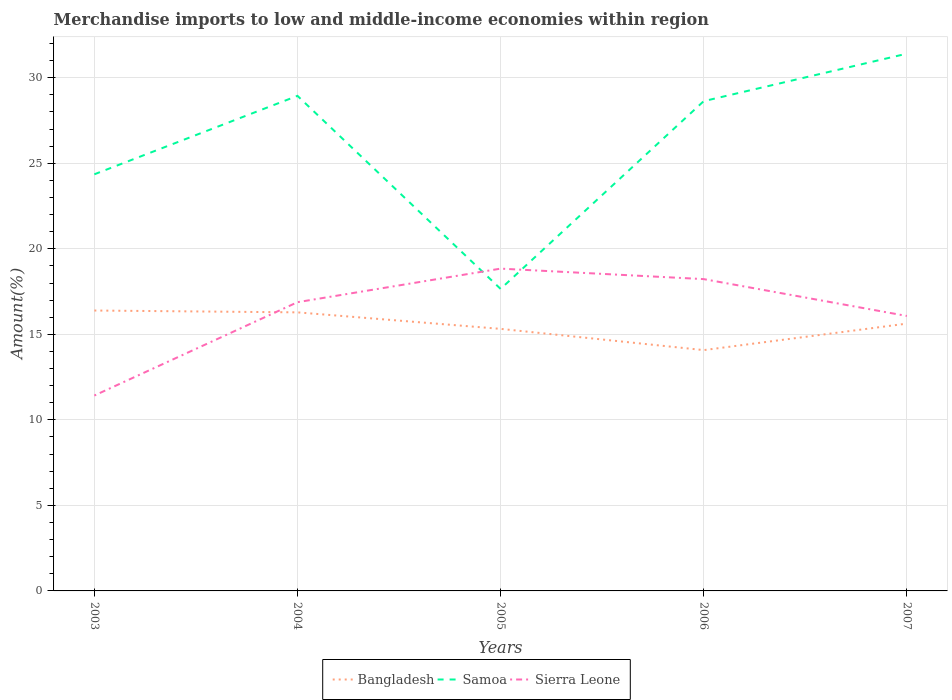Is the number of lines equal to the number of legend labels?
Give a very brief answer. Yes. Across all years, what is the maximum percentage of amount earned from merchandise imports in Samoa?
Provide a succinct answer. 17.66. In which year was the percentage of amount earned from merchandise imports in Bangladesh maximum?
Ensure brevity in your answer.  2006. What is the total percentage of amount earned from merchandise imports in Bangladesh in the graph?
Give a very brief answer. 1.24. What is the difference between the highest and the second highest percentage of amount earned from merchandise imports in Samoa?
Ensure brevity in your answer.  13.75. What is the difference between the highest and the lowest percentage of amount earned from merchandise imports in Samoa?
Provide a short and direct response. 3. Is the percentage of amount earned from merchandise imports in Bangladesh strictly greater than the percentage of amount earned from merchandise imports in Samoa over the years?
Offer a terse response. Yes. How many lines are there?
Ensure brevity in your answer.  3. What is the difference between two consecutive major ticks on the Y-axis?
Keep it short and to the point. 5. How are the legend labels stacked?
Keep it short and to the point. Horizontal. What is the title of the graph?
Your response must be concise. Merchandise imports to low and middle-income economies within region. Does "Grenada" appear as one of the legend labels in the graph?
Your answer should be very brief. No. What is the label or title of the Y-axis?
Provide a short and direct response. Amount(%). What is the Amount(%) of Bangladesh in 2003?
Make the answer very short. 16.39. What is the Amount(%) in Samoa in 2003?
Provide a succinct answer. 24.36. What is the Amount(%) of Sierra Leone in 2003?
Offer a terse response. 11.42. What is the Amount(%) in Bangladesh in 2004?
Make the answer very short. 16.28. What is the Amount(%) in Samoa in 2004?
Offer a terse response. 28.94. What is the Amount(%) of Sierra Leone in 2004?
Make the answer very short. 16.88. What is the Amount(%) in Bangladesh in 2005?
Your answer should be compact. 15.32. What is the Amount(%) of Samoa in 2005?
Provide a short and direct response. 17.66. What is the Amount(%) of Sierra Leone in 2005?
Keep it short and to the point. 18.84. What is the Amount(%) in Bangladesh in 2006?
Your answer should be very brief. 14.08. What is the Amount(%) in Samoa in 2006?
Offer a terse response. 28.63. What is the Amount(%) of Sierra Leone in 2006?
Offer a very short reply. 18.23. What is the Amount(%) of Bangladesh in 2007?
Your response must be concise. 15.63. What is the Amount(%) in Samoa in 2007?
Give a very brief answer. 31.41. What is the Amount(%) in Sierra Leone in 2007?
Make the answer very short. 16.07. Across all years, what is the maximum Amount(%) of Bangladesh?
Offer a terse response. 16.39. Across all years, what is the maximum Amount(%) in Samoa?
Your answer should be compact. 31.41. Across all years, what is the maximum Amount(%) of Sierra Leone?
Make the answer very short. 18.84. Across all years, what is the minimum Amount(%) of Bangladesh?
Your answer should be compact. 14.08. Across all years, what is the minimum Amount(%) in Samoa?
Your answer should be compact. 17.66. Across all years, what is the minimum Amount(%) in Sierra Leone?
Your response must be concise. 11.42. What is the total Amount(%) of Bangladesh in the graph?
Make the answer very short. 77.7. What is the total Amount(%) in Samoa in the graph?
Offer a very short reply. 130.99. What is the total Amount(%) in Sierra Leone in the graph?
Give a very brief answer. 81.44. What is the difference between the Amount(%) in Bangladesh in 2003 and that in 2004?
Your answer should be very brief. 0.11. What is the difference between the Amount(%) of Samoa in 2003 and that in 2004?
Your answer should be compact. -4.59. What is the difference between the Amount(%) in Sierra Leone in 2003 and that in 2004?
Your response must be concise. -5.46. What is the difference between the Amount(%) of Bangladesh in 2003 and that in 2005?
Offer a terse response. 1.07. What is the difference between the Amount(%) of Samoa in 2003 and that in 2005?
Your answer should be compact. 6.7. What is the difference between the Amount(%) in Sierra Leone in 2003 and that in 2005?
Your answer should be very brief. -7.42. What is the difference between the Amount(%) in Bangladesh in 2003 and that in 2006?
Your answer should be very brief. 2.31. What is the difference between the Amount(%) in Samoa in 2003 and that in 2006?
Your response must be concise. -4.28. What is the difference between the Amount(%) in Sierra Leone in 2003 and that in 2006?
Give a very brief answer. -6.81. What is the difference between the Amount(%) of Bangladesh in 2003 and that in 2007?
Your answer should be compact. 0.76. What is the difference between the Amount(%) of Samoa in 2003 and that in 2007?
Your answer should be compact. -7.05. What is the difference between the Amount(%) of Sierra Leone in 2003 and that in 2007?
Provide a short and direct response. -4.65. What is the difference between the Amount(%) of Bangladesh in 2004 and that in 2005?
Provide a succinct answer. 0.97. What is the difference between the Amount(%) in Samoa in 2004 and that in 2005?
Give a very brief answer. 11.29. What is the difference between the Amount(%) of Sierra Leone in 2004 and that in 2005?
Provide a short and direct response. -1.96. What is the difference between the Amount(%) in Bangladesh in 2004 and that in 2006?
Your response must be concise. 2.21. What is the difference between the Amount(%) in Samoa in 2004 and that in 2006?
Make the answer very short. 0.31. What is the difference between the Amount(%) in Sierra Leone in 2004 and that in 2006?
Give a very brief answer. -1.35. What is the difference between the Amount(%) of Bangladesh in 2004 and that in 2007?
Provide a succinct answer. 0.66. What is the difference between the Amount(%) in Samoa in 2004 and that in 2007?
Make the answer very short. -2.47. What is the difference between the Amount(%) in Sierra Leone in 2004 and that in 2007?
Provide a short and direct response. 0.81. What is the difference between the Amount(%) in Bangladesh in 2005 and that in 2006?
Your response must be concise. 1.24. What is the difference between the Amount(%) of Samoa in 2005 and that in 2006?
Your answer should be very brief. -10.98. What is the difference between the Amount(%) of Sierra Leone in 2005 and that in 2006?
Your answer should be compact. 0.61. What is the difference between the Amount(%) in Bangladesh in 2005 and that in 2007?
Your answer should be compact. -0.31. What is the difference between the Amount(%) of Samoa in 2005 and that in 2007?
Your answer should be very brief. -13.75. What is the difference between the Amount(%) of Sierra Leone in 2005 and that in 2007?
Keep it short and to the point. 2.77. What is the difference between the Amount(%) in Bangladesh in 2006 and that in 2007?
Provide a succinct answer. -1.55. What is the difference between the Amount(%) in Samoa in 2006 and that in 2007?
Give a very brief answer. -2.78. What is the difference between the Amount(%) in Sierra Leone in 2006 and that in 2007?
Provide a succinct answer. 2.15. What is the difference between the Amount(%) in Bangladesh in 2003 and the Amount(%) in Samoa in 2004?
Give a very brief answer. -12.55. What is the difference between the Amount(%) of Bangladesh in 2003 and the Amount(%) of Sierra Leone in 2004?
Your answer should be very brief. -0.49. What is the difference between the Amount(%) in Samoa in 2003 and the Amount(%) in Sierra Leone in 2004?
Provide a short and direct response. 7.48. What is the difference between the Amount(%) in Bangladesh in 2003 and the Amount(%) in Samoa in 2005?
Make the answer very short. -1.26. What is the difference between the Amount(%) of Bangladesh in 2003 and the Amount(%) of Sierra Leone in 2005?
Your response must be concise. -2.45. What is the difference between the Amount(%) of Samoa in 2003 and the Amount(%) of Sierra Leone in 2005?
Offer a terse response. 5.51. What is the difference between the Amount(%) of Bangladesh in 2003 and the Amount(%) of Samoa in 2006?
Offer a very short reply. -12.24. What is the difference between the Amount(%) in Bangladesh in 2003 and the Amount(%) in Sierra Leone in 2006?
Give a very brief answer. -1.84. What is the difference between the Amount(%) of Samoa in 2003 and the Amount(%) of Sierra Leone in 2006?
Offer a terse response. 6.13. What is the difference between the Amount(%) in Bangladesh in 2003 and the Amount(%) in Samoa in 2007?
Provide a short and direct response. -15.02. What is the difference between the Amount(%) of Bangladesh in 2003 and the Amount(%) of Sierra Leone in 2007?
Offer a terse response. 0.32. What is the difference between the Amount(%) in Samoa in 2003 and the Amount(%) in Sierra Leone in 2007?
Keep it short and to the point. 8.28. What is the difference between the Amount(%) in Bangladesh in 2004 and the Amount(%) in Samoa in 2005?
Provide a short and direct response. -1.37. What is the difference between the Amount(%) of Bangladesh in 2004 and the Amount(%) of Sierra Leone in 2005?
Make the answer very short. -2.56. What is the difference between the Amount(%) in Samoa in 2004 and the Amount(%) in Sierra Leone in 2005?
Keep it short and to the point. 10.1. What is the difference between the Amount(%) in Bangladesh in 2004 and the Amount(%) in Samoa in 2006?
Provide a short and direct response. -12.35. What is the difference between the Amount(%) in Bangladesh in 2004 and the Amount(%) in Sierra Leone in 2006?
Ensure brevity in your answer.  -1.94. What is the difference between the Amount(%) in Samoa in 2004 and the Amount(%) in Sierra Leone in 2006?
Offer a terse response. 10.71. What is the difference between the Amount(%) in Bangladesh in 2004 and the Amount(%) in Samoa in 2007?
Offer a terse response. -15.12. What is the difference between the Amount(%) of Bangladesh in 2004 and the Amount(%) of Sierra Leone in 2007?
Keep it short and to the point. 0.21. What is the difference between the Amount(%) in Samoa in 2004 and the Amount(%) in Sierra Leone in 2007?
Make the answer very short. 12.87. What is the difference between the Amount(%) of Bangladesh in 2005 and the Amount(%) of Samoa in 2006?
Offer a terse response. -13.31. What is the difference between the Amount(%) in Bangladesh in 2005 and the Amount(%) in Sierra Leone in 2006?
Offer a very short reply. -2.91. What is the difference between the Amount(%) of Samoa in 2005 and the Amount(%) of Sierra Leone in 2006?
Ensure brevity in your answer.  -0.57. What is the difference between the Amount(%) in Bangladesh in 2005 and the Amount(%) in Samoa in 2007?
Ensure brevity in your answer.  -16.09. What is the difference between the Amount(%) in Bangladesh in 2005 and the Amount(%) in Sierra Leone in 2007?
Provide a short and direct response. -0.75. What is the difference between the Amount(%) of Samoa in 2005 and the Amount(%) of Sierra Leone in 2007?
Give a very brief answer. 1.58. What is the difference between the Amount(%) in Bangladesh in 2006 and the Amount(%) in Samoa in 2007?
Ensure brevity in your answer.  -17.33. What is the difference between the Amount(%) of Bangladesh in 2006 and the Amount(%) of Sierra Leone in 2007?
Ensure brevity in your answer.  -2. What is the difference between the Amount(%) in Samoa in 2006 and the Amount(%) in Sierra Leone in 2007?
Your answer should be very brief. 12.56. What is the average Amount(%) of Bangladesh per year?
Your answer should be very brief. 15.54. What is the average Amount(%) in Samoa per year?
Your answer should be very brief. 26.2. What is the average Amount(%) in Sierra Leone per year?
Ensure brevity in your answer.  16.29. In the year 2003, what is the difference between the Amount(%) of Bangladesh and Amount(%) of Samoa?
Provide a short and direct response. -7.96. In the year 2003, what is the difference between the Amount(%) of Bangladesh and Amount(%) of Sierra Leone?
Offer a terse response. 4.97. In the year 2003, what is the difference between the Amount(%) in Samoa and Amount(%) in Sierra Leone?
Give a very brief answer. 12.93. In the year 2004, what is the difference between the Amount(%) of Bangladesh and Amount(%) of Samoa?
Your response must be concise. -12.66. In the year 2004, what is the difference between the Amount(%) of Bangladesh and Amount(%) of Sierra Leone?
Give a very brief answer. -0.59. In the year 2004, what is the difference between the Amount(%) in Samoa and Amount(%) in Sierra Leone?
Make the answer very short. 12.06. In the year 2005, what is the difference between the Amount(%) in Bangladesh and Amount(%) in Samoa?
Your answer should be compact. -2.34. In the year 2005, what is the difference between the Amount(%) in Bangladesh and Amount(%) in Sierra Leone?
Keep it short and to the point. -3.52. In the year 2005, what is the difference between the Amount(%) of Samoa and Amount(%) of Sierra Leone?
Keep it short and to the point. -1.19. In the year 2006, what is the difference between the Amount(%) of Bangladesh and Amount(%) of Samoa?
Provide a succinct answer. -14.55. In the year 2006, what is the difference between the Amount(%) of Bangladesh and Amount(%) of Sierra Leone?
Offer a very short reply. -4.15. In the year 2006, what is the difference between the Amount(%) of Samoa and Amount(%) of Sierra Leone?
Make the answer very short. 10.4. In the year 2007, what is the difference between the Amount(%) of Bangladesh and Amount(%) of Samoa?
Keep it short and to the point. -15.78. In the year 2007, what is the difference between the Amount(%) of Bangladesh and Amount(%) of Sierra Leone?
Your answer should be compact. -0.45. In the year 2007, what is the difference between the Amount(%) of Samoa and Amount(%) of Sierra Leone?
Offer a terse response. 15.33. What is the ratio of the Amount(%) in Bangladesh in 2003 to that in 2004?
Provide a short and direct response. 1.01. What is the ratio of the Amount(%) of Samoa in 2003 to that in 2004?
Ensure brevity in your answer.  0.84. What is the ratio of the Amount(%) in Sierra Leone in 2003 to that in 2004?
Provide a short and direct response. 0.68. What is the ratio of the Amount(%) in Bangladesh in 2003 to that in 2005?
Ensure brevity in your answer.  1.07. What is the ratio of the Amount(%) in Samoa in 2003 to that in 2005?
Your answer should be very brief. 1.38. What is the ratio of the Amount(%) of Sierra Leone in 2003 to that in 2005?
Offer a terse response. 0.61. What is the ratio of the Amount(%) in Bangladesh in 2003 to that in 2006?
Provide a short and direct response. 1.16. What is the ratio of the Amount(%) in Samoa in 2003 to that in 2006?
Offer a very short reply. 0.85. What is the ratio of the Amount(%) of Sierra Leone in 2003 to that in 2006?
Keep it short and to the point. 0.63. What is the ratio of the Amount(%) in Bangladesh in 2003 to that in 2007?
Provide a succinct answer. 1.05. What is the ratio of the Amount(%) in Samoa in 2003 to that in 2007?
Provide a succinct answer. 0.78. What is the ratio of the Amount(%) of Sierra Leone in 2003 to that in 2007?
Offer a very short reply. 0.71. What is the ratio of the Amount(%) of Bangladesh in 2004 to that in 2005?
Offer a terse response. 1.06. What is the ratio of the Amount(%) in Samoa in 2004 to that in 2005?
Give a very brief answer. 1.64. What is the ratio of the Amount(%) of Sierra Leone in 2004 to that in 2005?
Your response must be concise. 0.9. What is the ratio of the Amount(%) of Bangladesh in 2004 to that in 2006?
Your response must be concise. 1.16. What is the ratio of the Amount(%) in Samoa in 2004 to that in 2006?
Keep it short and to the point. 1.01. What is the ratio of the Amount(%) in Sierra Leone in 2004 to that in 2006?
Offer a terse response. 0.93. What is the ratio of the Amount(%) in Bangladesh in 2004 to that in 2007?
Provide a short and direct response. 1.04. What is the ratio of the Amount(%) in Samoa in 2004 to that in 2007?
Provide a succinct answer. 0.92. What is the ratio of the Amount(%) of Sierra Leone in 2004 to that in 2007?
Provide a short and direct response. 1.05. What is the ratio of the Amount(%) of Bangladesh in 2005 to that in 2006?
Your response must be concise. 1.09. What is the ratio of the Amount(%) of Samoa in 2005 to that in 2006?
Your answer should be very brief. 0.62. What is the ratio of the Amount(%) in Sierra Leone in 2005 to that in 2006?
Your response must be concise. 1.03. What is the ratio of the Amount(%) in Bangladesh in 2005 to that in 2007?
Your response must be concise. 0.98. What is the ratio of the Amount(%) of Samoa in 2005 to that in 2007?
Make the answer very short. 0.56. What is the ratio of the Amount(%) of Sierra Leone in 2005 to that in 2007?
Give a very brief answer. 1.17. What is the ratio of the Amount(%) in Bangladesh in 2006 to that in 2007?
Your answer should be compact. 0.9. What is the ratio of the Amount(%) in Samoa in 2006 to that in 2007?
Keep it short and to the point. 0.91. What is the ratio of the Amount(%) in Sierra Leone in 2006 to that in 2007?
Provide a succinct answer. 1.13. What is the difference between the highest and the second highest Amount(%) in Bangladesh?
Your answer should be very brief. 0.11. What is the difference between the highest and the second highest Amount(%) of Samoa?
Give a very brief answer. 2.47. What is the difference between the highest and the second highest Amount(%) of Sierra Leone?
Provide a short and direct response. 0.61. What is the difference between the highest and the lowest Amount(%) in Bangladesh?
Offer a terse response. 2.31. What is the difference between the highest and the lowest Amount(%) in Samoa?
Your response must be concise. 13.75. What is the difference between the highest and the lowest Amount(%) in Sierra Leone?
Your answer should be very brief. 7.42. 